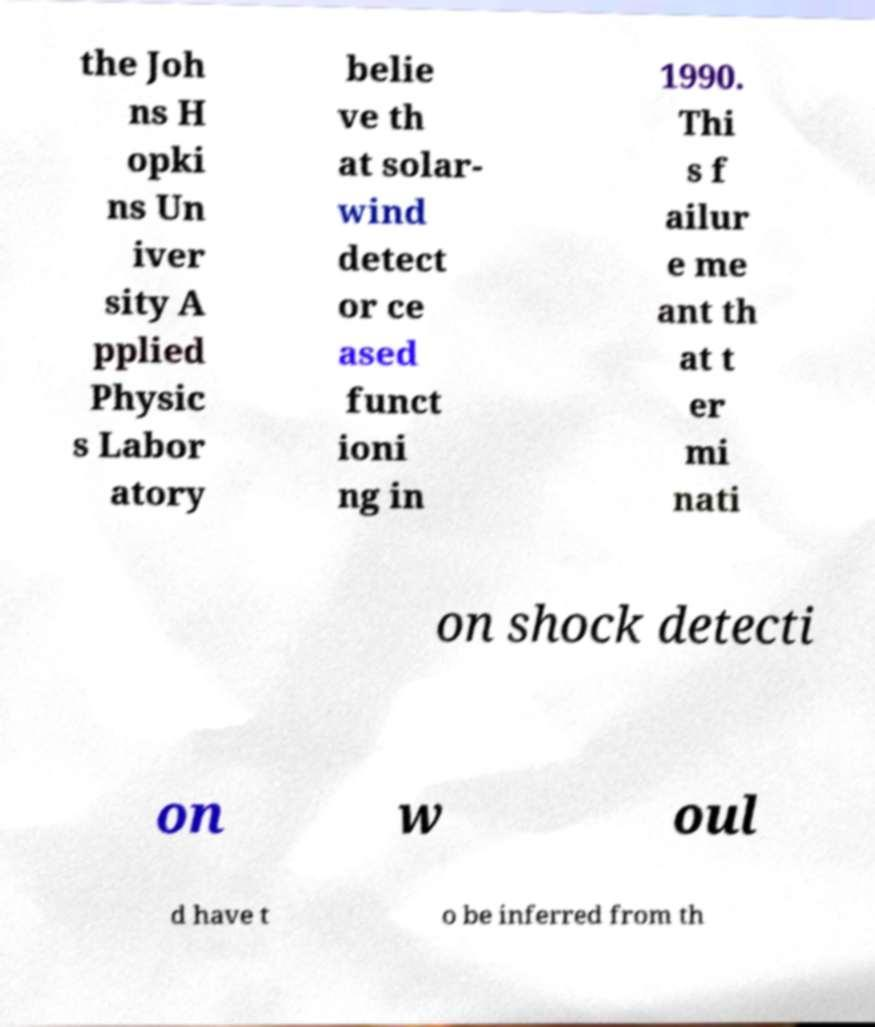Please read and relay the text visible in this image. What does it say? the Joh ns H opki ns Un iver sity A pplied Physic s Labor atory belie ve th at solar- wind detect or ce ased funct ioni ng in 1990. Thi s f ailur e me ant th at t er mi nati on shock detecti on w oul d have t o be inferred from th 